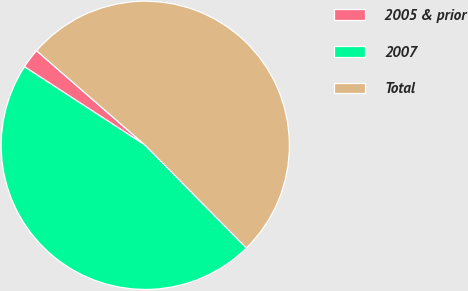Convert chart to OTSL. <chart><loc_0><loc_0><loc_500><loc_500><pie_chart><fcel>2005 & prior<fcel>2007<fcel>Total<nl><fcel>2.22%<fcel>46.56%<fcel>51.22%<nl></chart> 